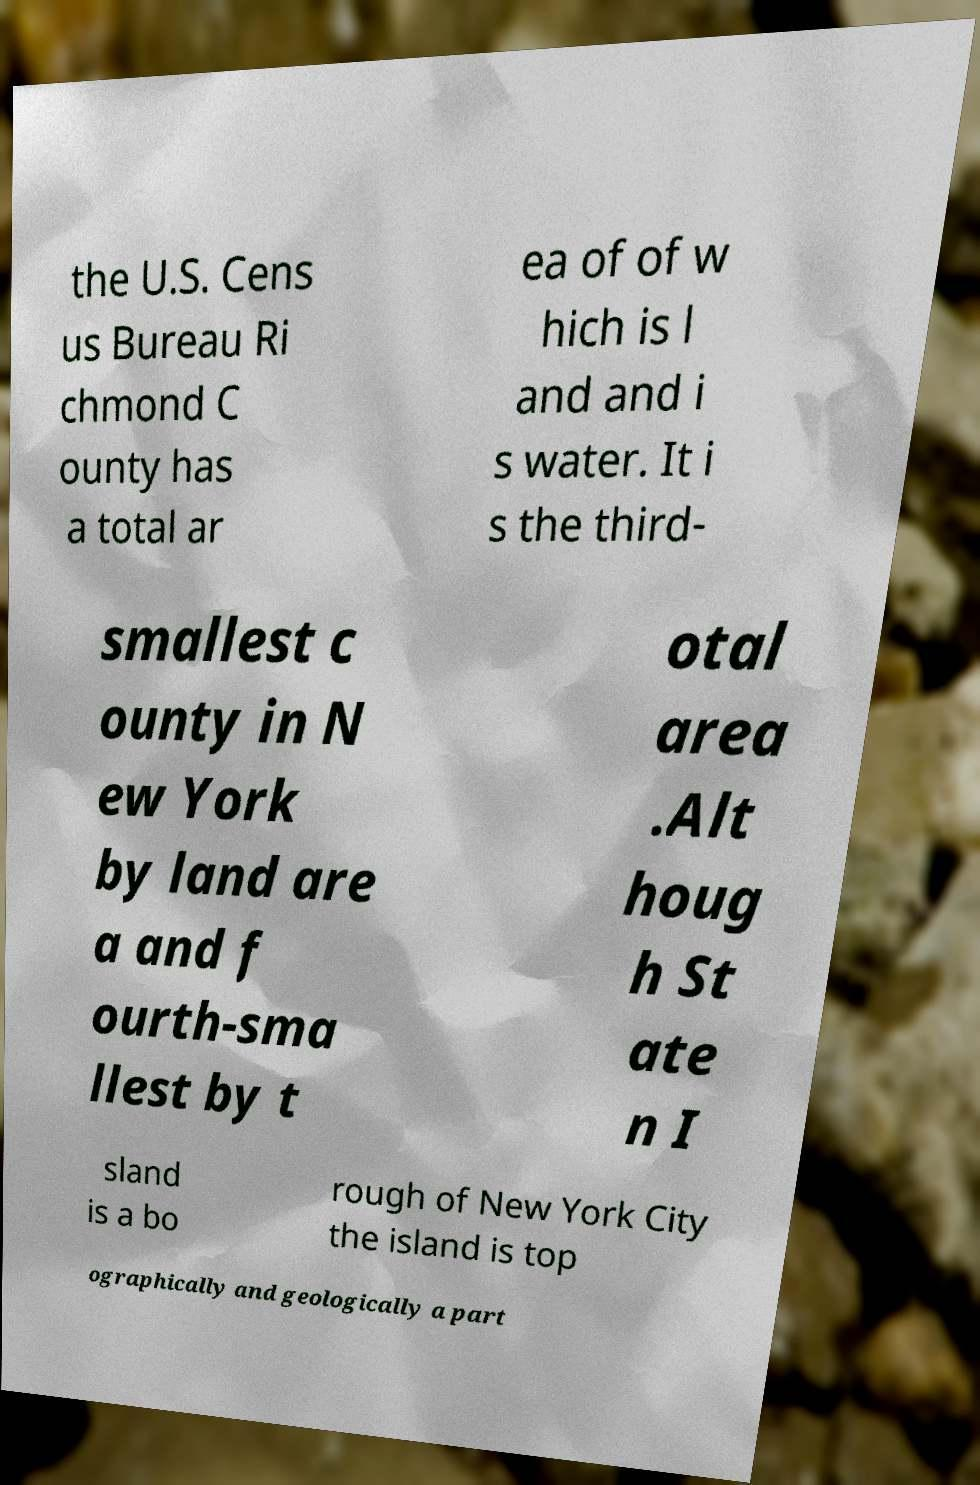What messages or text are displayed in this image? I need them in a readable, typed format. the U.S. Cens us Bureau Ri chmond C ounty has a total ar ea of of w hich is l and and i s water. It i s the third- smallest c ounty in N ew York by land are a and f ourth-sma llest by t otal area .Alt houg h St ate n I sland is a bo rough of New York City the island is top ographically and geologically a part 